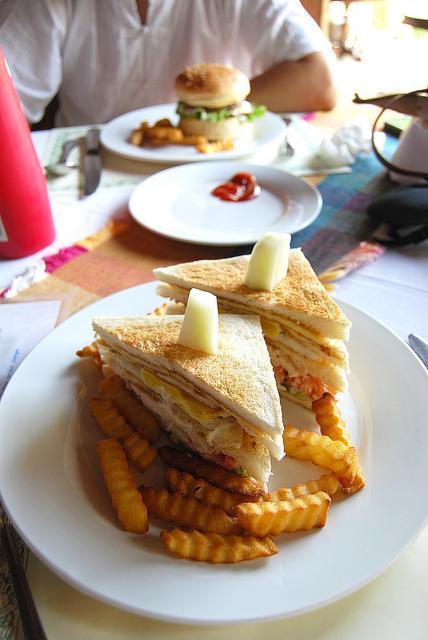How many fries on the plate?
Give a very brief answer. 11. How many sandwiches can be seen?
Give a very brief answer. 3. How many chairs at near the window?
Give a very brief answer. 0. 